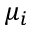<formula> <loc_0><loc_0><loc_500><loc_500>\mu _ { i }</formula> 